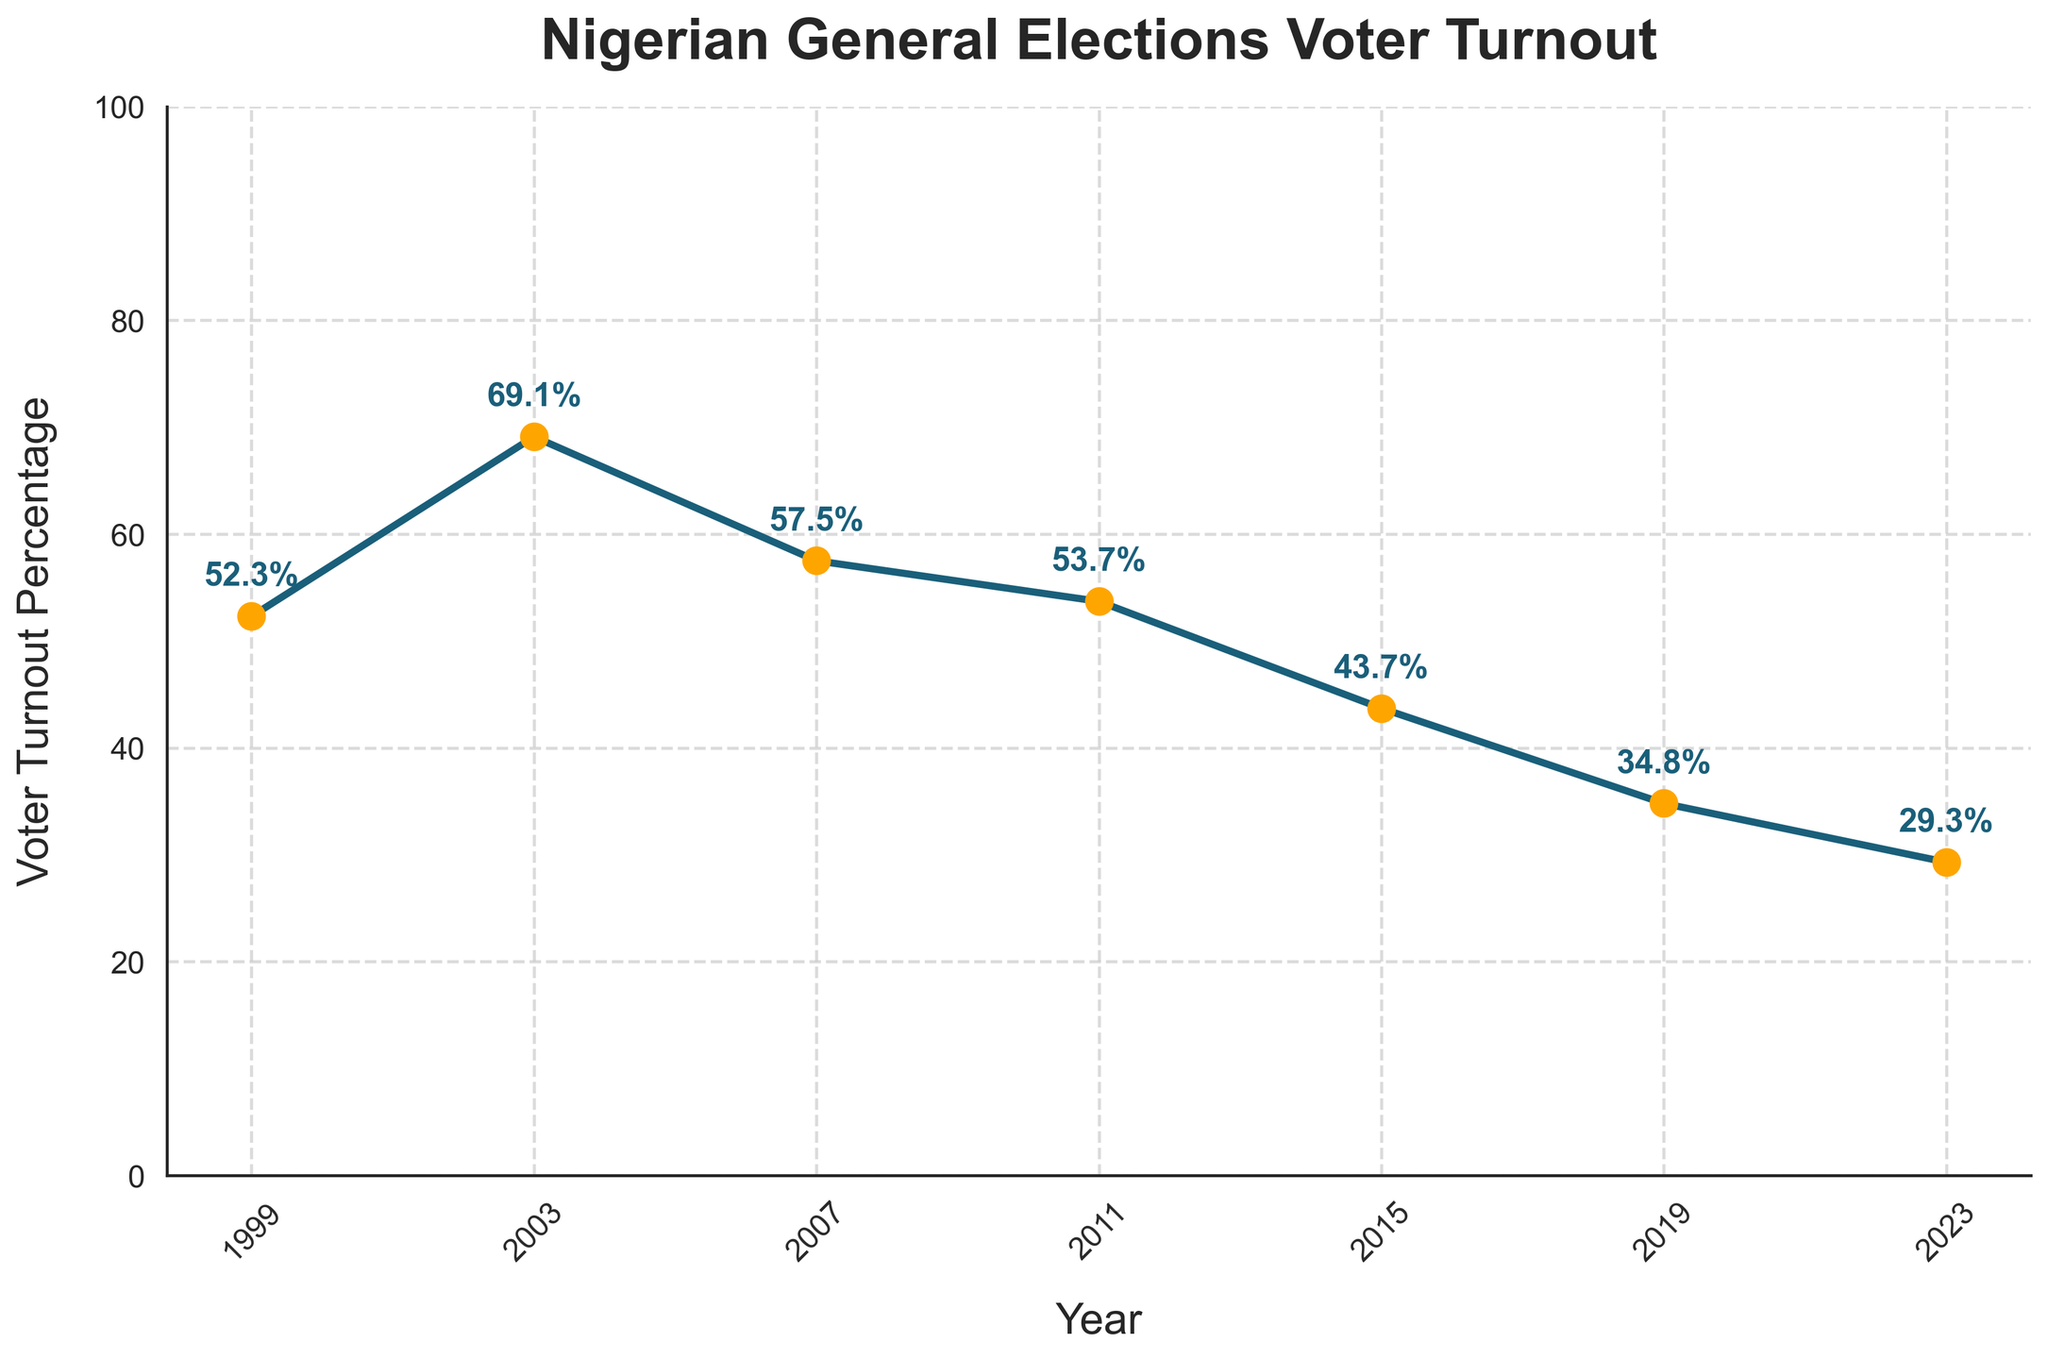Which year had the highest voter turnout percentage? By examining the figure, we can pinpoint the peak value in the voter turnout line, which occurs in 2003.
Answer: 2003 How much did the voter turnout decrease from 2003 to 2019? Looking at the voter turnout percentages for 2003 (69.1%) and 2019 (34.8%), the difference can be calculated as 69.1 - 34.8 = 34.3%.
Answer: 34.3% What is the average voter turnout percentage from 1999 to 2023? To find the average, sum all the voter turnout percentages and divide by the number of years: (52.3 + 69.1 + 57.5 + 53.7 + 43.7 + 34.8 + 29.3) / 7 ≈ 48.06%.
Answer: 48.06% Between which consecutive years was the largest decrease in voter turnout? By comparing the changes in voter turnout between consecutive years (2003-2007, 2007-2011, 2011-2015, 2015-2019, and 2019-2023), the largest drop occurs from 2011 to 2015, which is 53.7% - 43.7% = 10%.
Answer: 2011 to 2015 Is the voter turnout percentage in 1999 greater than 2023? Comparing the voter turnout percentages of 1999 (52.3%) and 2023 (29.3%), it is evident that the 1999 value is larger.
Answer: Yes What's the difference in voter turnout percentage between the year with the highest and the year with the lowest turnout? The highest turnout is in 2003 (69.1%) and the lowest is in 2023 (29.3%). The difference is 69.1 - 29.3 = 39.8%.
Answer: 39.8% Describe the overall trend observed in the voter turnout percentages from 1999 to 2023. The trend shows an initial increase till 2003, followed by a general decline with some fluctuations down to the lowest point in 2023.
Answer: Declining Which election year is represented by the third marker on the line chart? Following the markers from left to right, the third marker corresponds to the year 2007.
Answer: 2007 How does the 2015 voter turnout compare visually to the 2019 voter turnout? Visually, the 2015 marker is positioned higher than the 2019 marker, indicating a higher voter turnout in 2015 (43.7%) compared to 2019 (34.8%).
Answer: Higher in 2015 